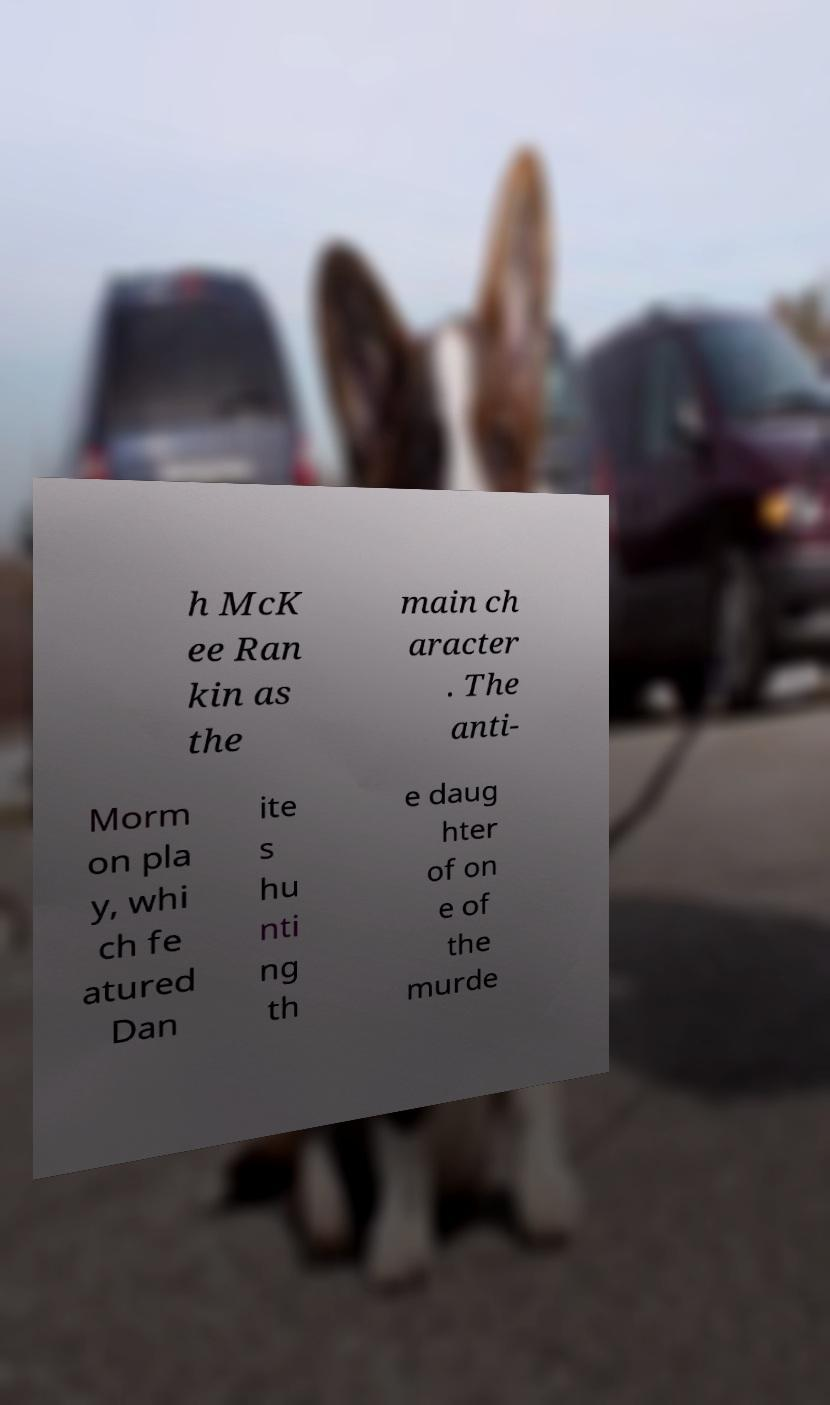For documentation purposes, I need the text within this image transcribed. Could you provide that? h McK ee Ran kin as the main ch aracter . The anti- Morm on pla y, whi ch fe atured Dan ite s hu nti ng th e daug hter of on e of the murde 